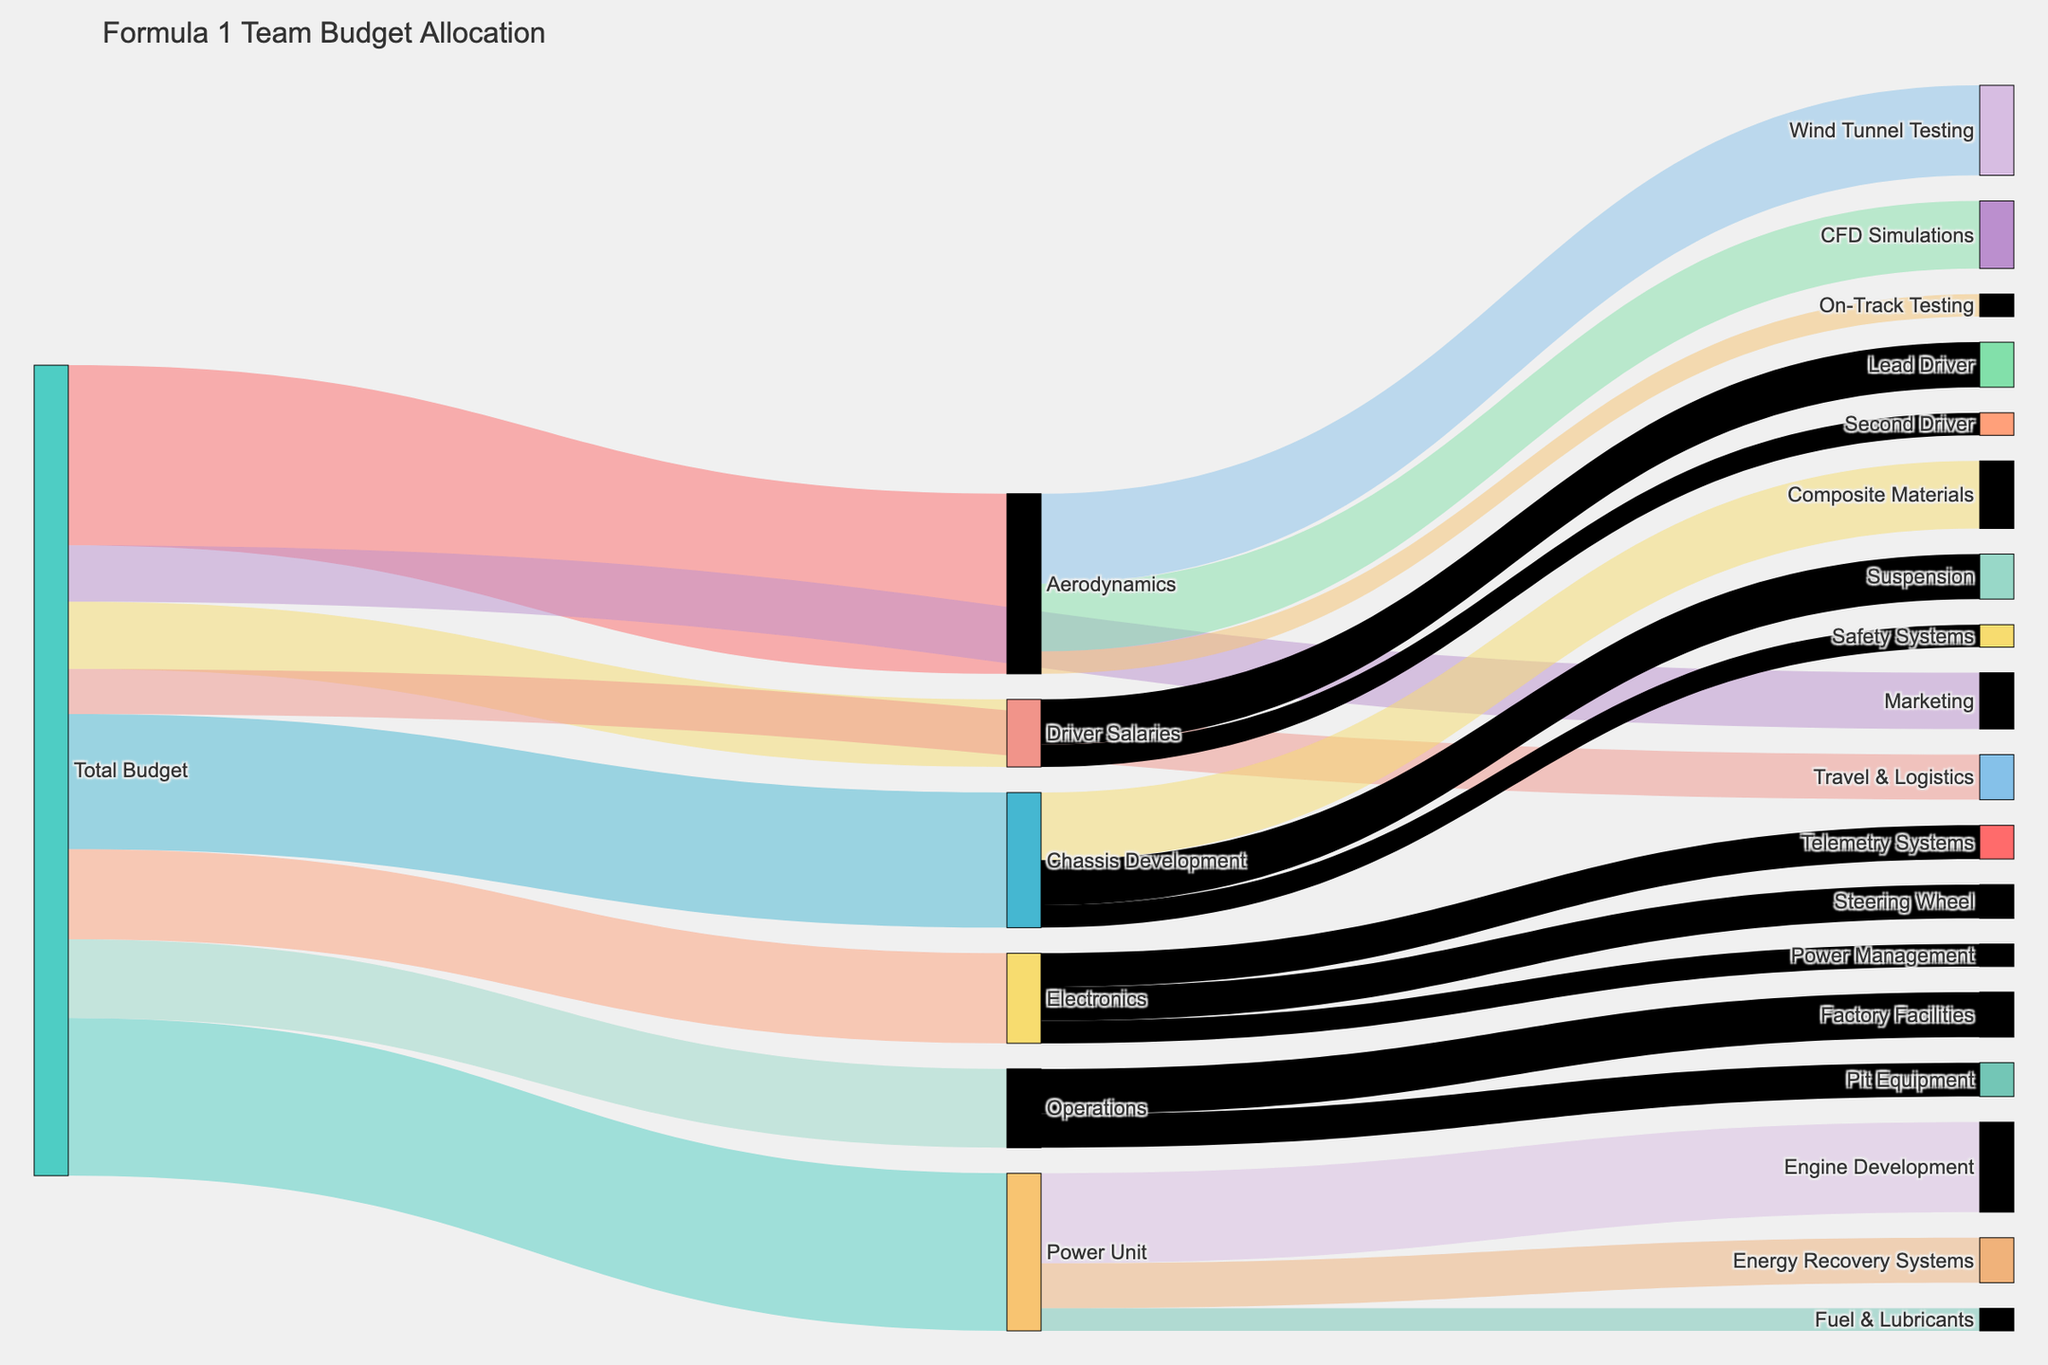What is the total budget allocated to Aerodynamics? To find the total budget allocated to Aerodynamics, refer to the link originating from "Total Budget" and pointing to "Aerodynamics". The value is clearly provided.
Answer: $80,000,000 Which department receives the least funding from the total budget? Compare the values for all departments originating from "Total Budget". The department with the smallest value is the one that receives the least funding.
Answer: Travel & Logistics How much more is allocated to Power Unit compared to Chassis Development? Identify the values for Power Unit and Chassis Development (from Total Budget). Subtract the value for Chassis Development from the value for Power Unit: $70,000,000 - $60,000,000.
Answer: $10,000,000 What is the total allocation for all components under Electronics? Sum the values for Steering Wheel, Telemetry Systems, and Power Management under Electronics: $15,000,000 + $15,000,000 + $10,000,000.
Answer: $40,000,000 Which subprocess in Aerodynamics is allocated the most budget? Review the values for Wind Tunnel Testing, CFD Simulations, and On-Track Testing under Aerodynamics. The one with the highest value is allocated the most budget.
Answer: Wind Tunnel Testing What is the combined budget for Driver Salaries and Marketing? Sum the values for Driver Salaries and Marketing from the Total Budget: $30,000,000 + $25,000,000.
Answer: $55,000,000 How much more is allocated to the Lead Driver compared to the Second Driver? Identify the values for Lead Driver and Second Driver under Driver Salaries. Subtract the value for Second Driver from the value for Lead Driver: $20,000,000 - $10,000,000.
Answer: $10,000,000 What is the total budget for Operations, and how is it distributed among its components? The total budget for Operations is found by looking at the value from Total Budget. The components (Factory Facilities and Pit Equipment) can be reviewed individually. Sum their values: $20,000,000 + $15,000,000 = $35,000,000, and note their distribution.
Answer: $35,000,000, distributed as $20,000,000 for Factory Facilities and $15,000,000 for Pit Equipment What percentage of the total Aerodynamics budget is spent on CFD Simulations? First, find the total Aerodynamics budget: $80,000,000. Then identify the amount for CFD Simulations: $30,000,000. Finally, calculate the percentage: ($30,000,000 / $80,000,000) * 100.
Answer: 37.5% What is the total budget allocated across all departments? Sum all values originating from Total Budget for each department: $80,000,000 + $70,000,000 + $60,000,000 + $40,000,000 + $35,000,000 + $30,000,000 + $25,000,000 + $20,000,000.
Answer: $360,000,000 